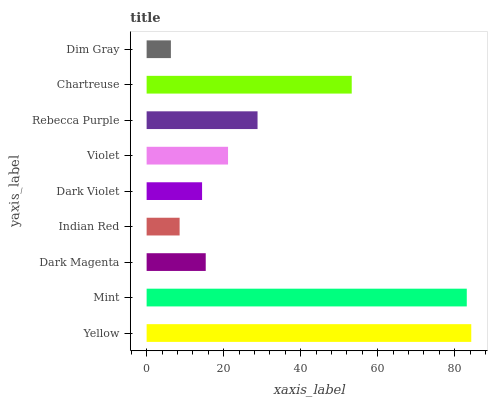Is Dim Gray the minimum?
Answer yes or no. Yes. Is Yellow the maximum?
Answer yes or no. Yes. Is Mint the minimum?
Answer yes or no. No. Is Mint the maximum?
Answer yes or no. No. Is Yellow greater than Mint?
Answer yes or no. Yes. Is Mint less than Yellow?
Answer yes or no. Yes. Is Mint greater than Yellow?
Answer yes or no. No. Is Yellow less than Mint?
Answer yes or no. No. Is Violet the high median?
Answer yes or no. Yes. Is Violet the low median?
Answer yes or no. Yes. Is Rebecca Purple the high median?
Answer yes or no. No. Is Dim Gray the low median?
Answer yes or no. No. 